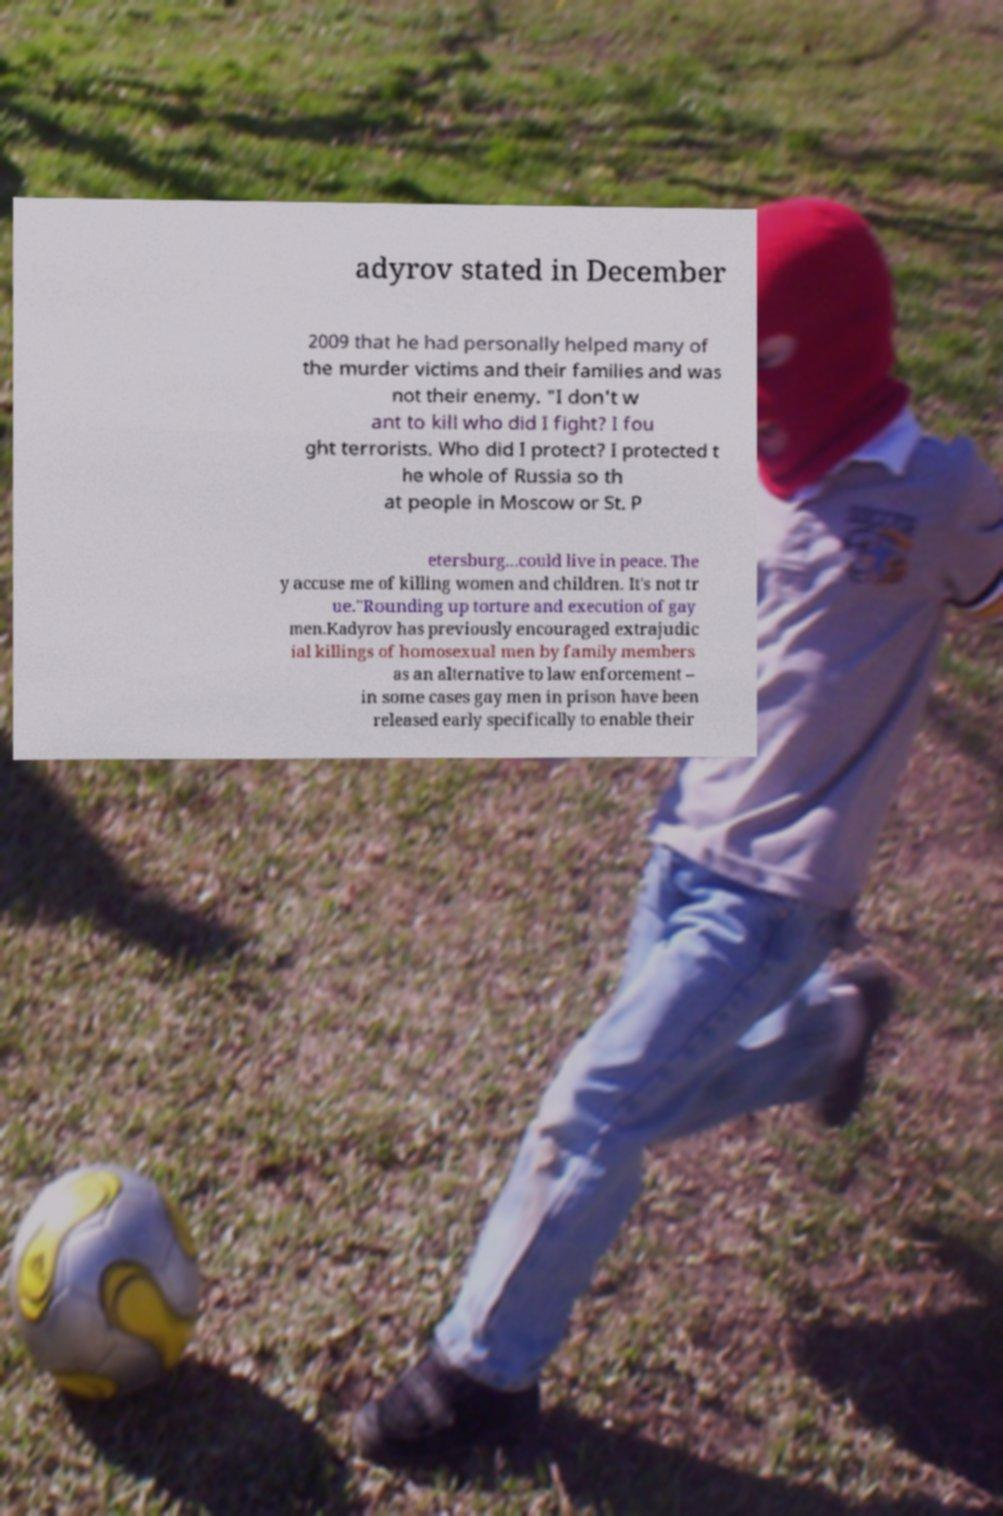For documentation purposes, I need the text within this image transcribed. Could you provide that? adyrov stated in December 2009 that he had personally helped many of the murder victims and their families and was not their enemy. "I don't w ant to kill who did I fight? I fou ght terrorists. Who did I protect? I protected t he whole of Russia so th at people in Moscow or St. P etersburg...could live in peace. The y accuse me of killing women and children. It's not tr ue."Rounding up torture and execution of gay men.Kadyrov has previously encouraged extrajudic ial killings of homosexual men by family members as an alternative to law enforcement – in some cases gay men in prison have been released early specifically to enable their 